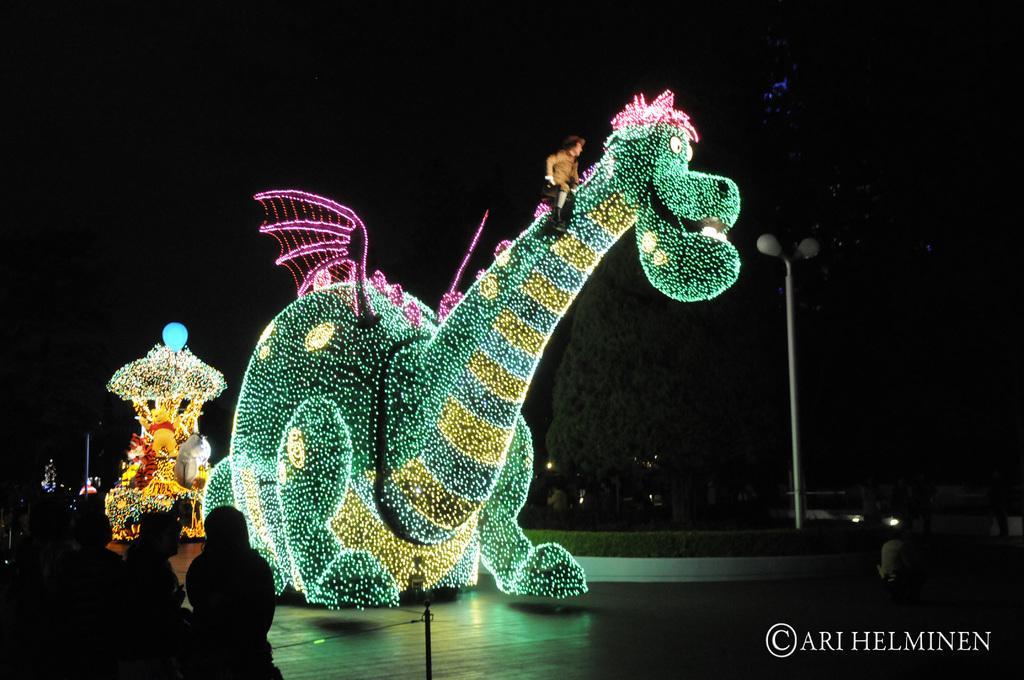Please provide a concise description of this image. Here in this picture we can see dragon like structures present on the ground, that are fully covered with lights and we can see a person present on the dragon and beside it we can see light posts present and we can also see vehicles present on the road and we can also see trees present and on the left side we can see people standing and watching. 